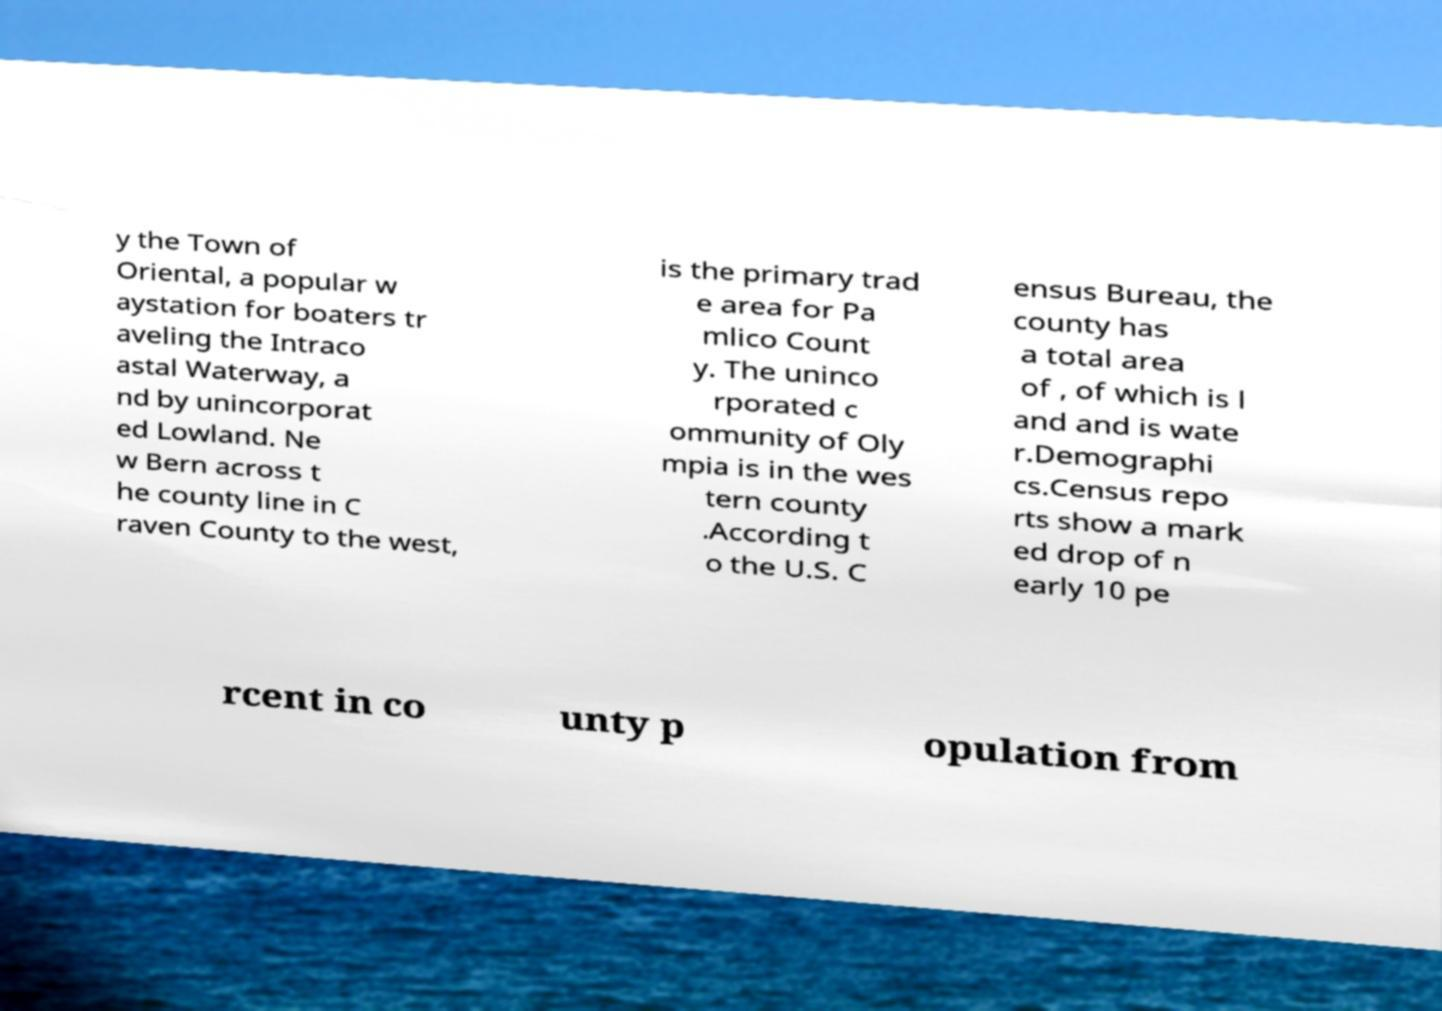Can you read and provide the text displayed in the image?This photo seems to have some interesting text. Can you extract and type it out for me? y the Town of Oriental, a popular w aystation for boaters tr aveling the Intraco astal Waterway, a nd by unincorporat ed Lowland. Ne w Bern across t he county line in C raven County to the west, is the primary trad e area for Pa mlico Count y. The uninco rporated c ommunity of Oly mpia is in the wes tern county .According t o the U.S. C ensus Bureau, the county has a total area of , of which is l and and is wate r.Demographi cs.Census repo rts show a mark ed drop of n early 10 pe rcent in co unty p opulation from 